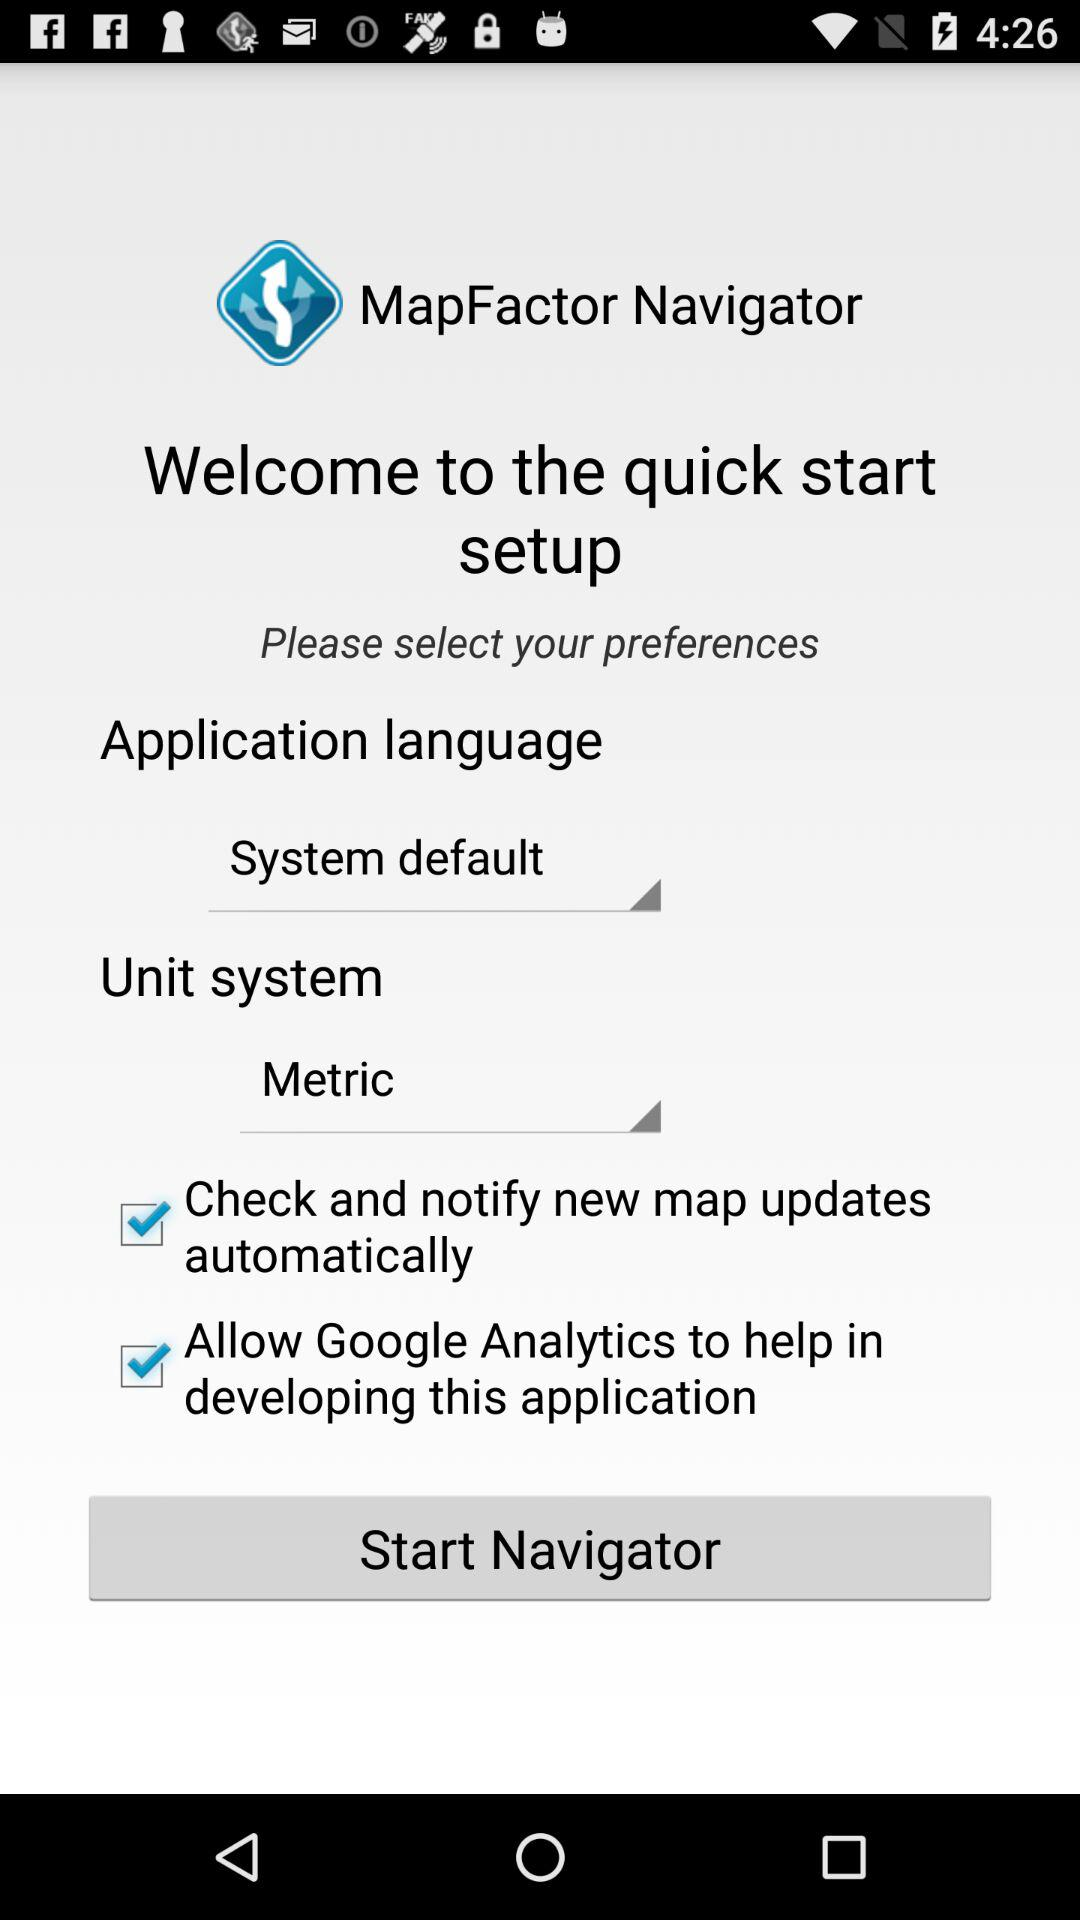Which is the selected checkbox? The selected checkboxes are "Check and notify new map updates automatically" and "Allow Google Analytics to help in developing this application". 